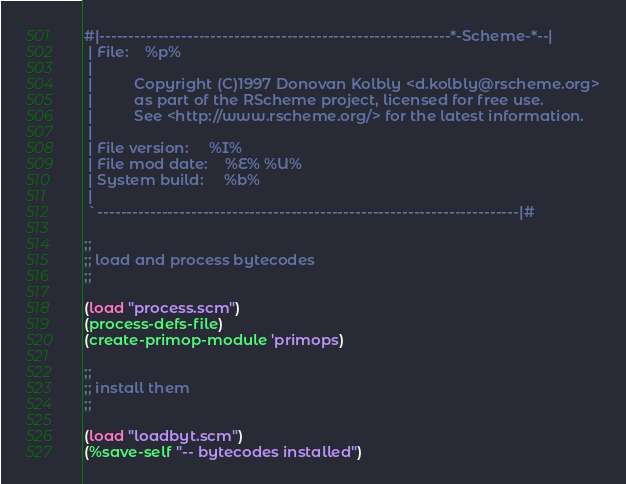<code> <loc_0><loc_0><loc_500><loc_500><_Scheme_>#|------------------------------------------------------------*-Scheme-*--|
 | File:    %p%
 |
 |          Copyright (C)1997 Donovan Kolbly <d.kolbly@rscheme.org>
 |          as part of the RScheme project, licensed for free use.
 |          See <http://www.rscheme.org/> for the latest information.
 |
 | File version:     %I%
 | File mod date:    %E% %U%
 | System build:     %b%
 |
 `------------------------------------------------------------------------|#

;;
;; load and process bytecodes
;;

(load "process.scm")
(process-defs-file)
(create-primop-module 'primops)

;;
;; install them
;;

(load "loadbyt.scm")
(%save-self "-- bytecodes installed")
</code> 